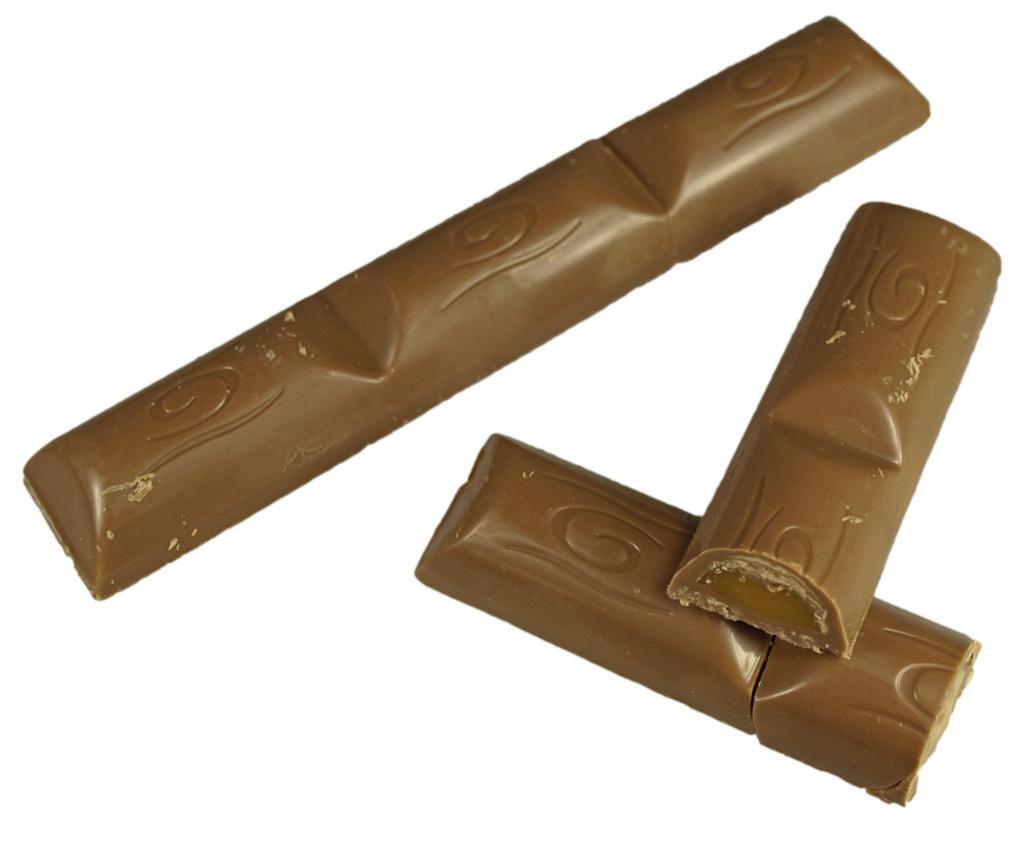Please provide a concise description of this image. In this picture we can observe a chocolate which is in brown color. The background is in white color. 